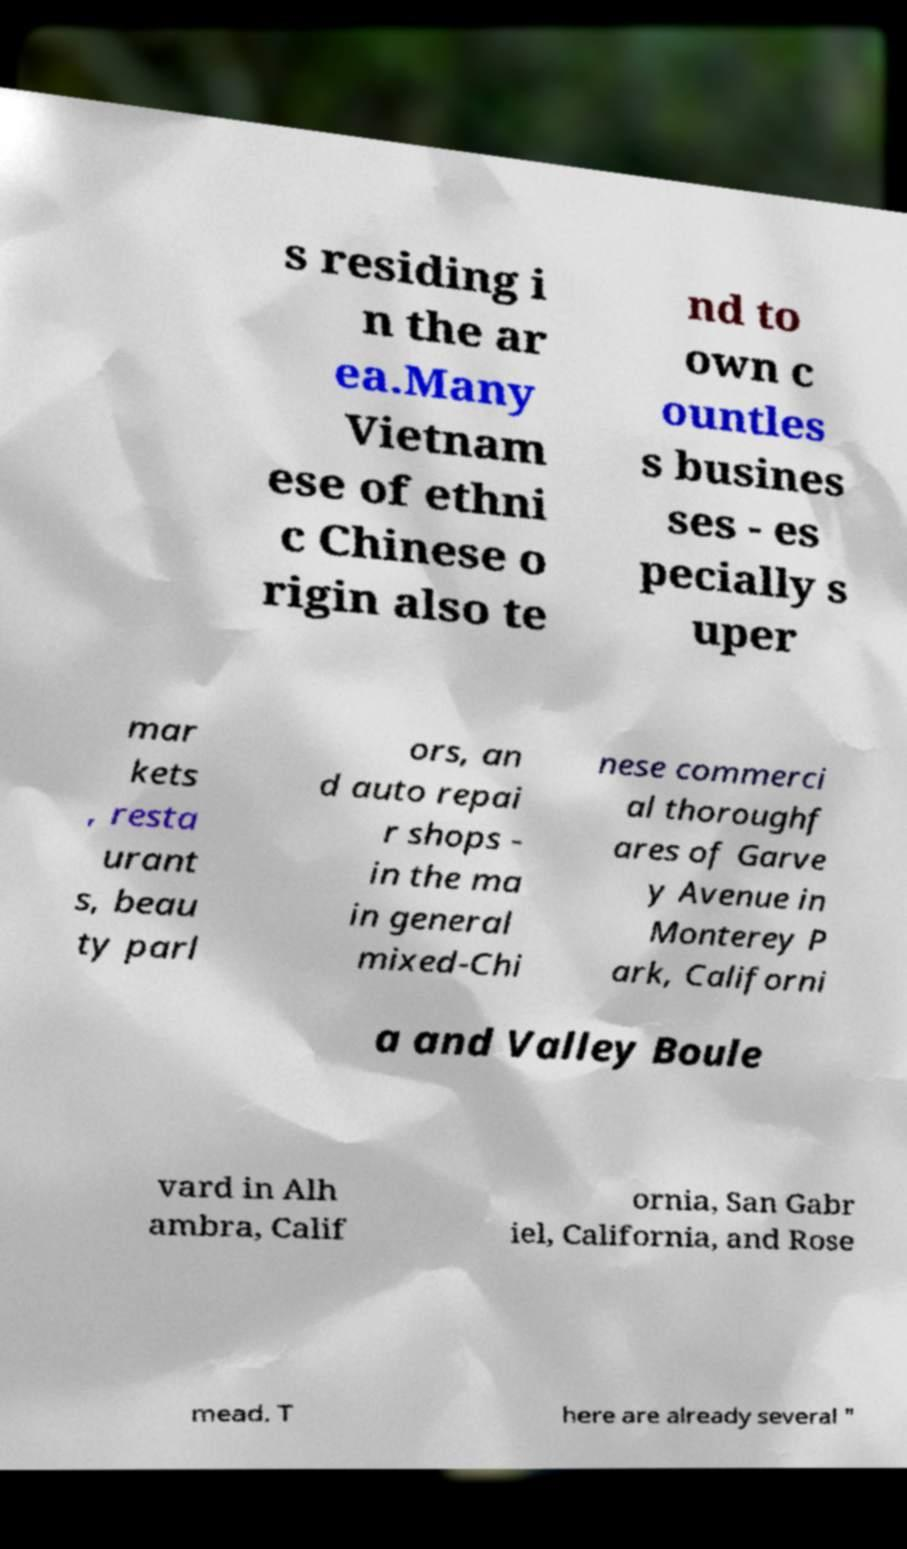For documentation purposes, I need the text within this image transcribed. Could you provide that? s residing i n the ar ea.Many Vietnam ese of ethni c Chinese o rigin also te nd to own c ountles s busines ses - es pecially s uper mar kets , resta urant s, beau ty parl ors, an d auto repai r shops - in the ma in general mixed-Chi nese commerci al thoroughf ares of Garve y Avenue in Monterey P ark, Californi a and Valley Boule vard in Alh ambra, Calif ornia, San Gabr iel, California, and Rose mead. T here are already several " 